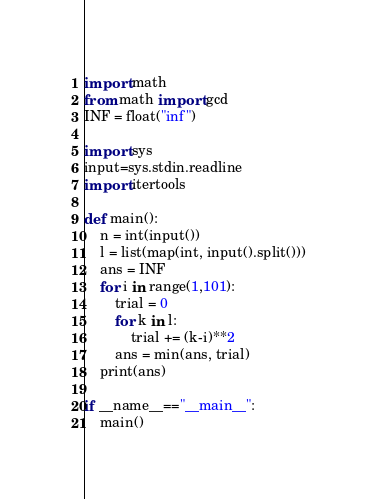<code> <loc_0><loc_0><loc_500><loc_500><_Python_>import math
from math import gcd
INF = float("inf")

import sys
input=sys.stdin.readline
import itertools

def main():
    n = int(input())
    l = list(map(int, input().split()))
    ans = INF
    for i in range(1,101):
        trial = 0
        for k in l:
            trial += (k-i)**2
        ans = min(ans, trial)
    print(ans)

if __name__=="__main__":
    main()
</code> 